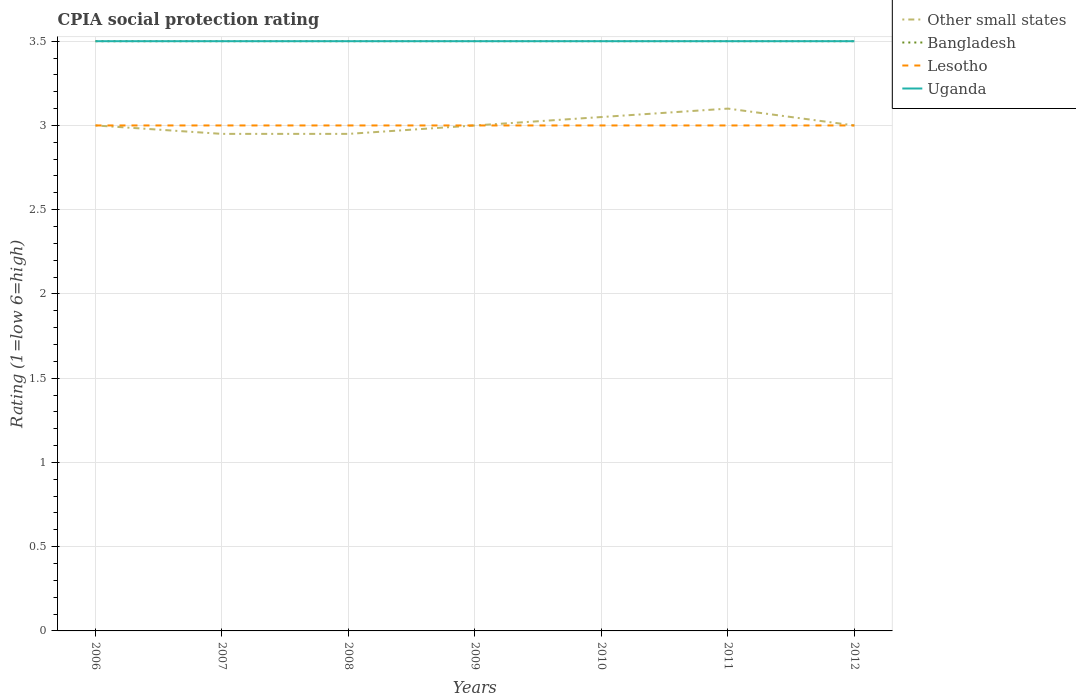How many different coloured lines are there?
Your answer should be very brief. 4. Does the line corresponding to Other small states intersect with the line corresponding to Bangladesh?
Offer a very short reply. No. Is the number of lines equal to the number of legend labels?
Your answer should be very brief. Yes. Across all years, what is the maximum CPIA rating in Lesotho?
Your response must be concise. 3. In which year was the CPIA rating in Other small states maximum?
Provide a succinct answer. 2007. What is the total CPIA rating in Uganda in the graph?
Your response must be concise. 0. What is the difference between the highest and the second highest CPIA rating in Uganda?
Offer a very short reply. 0. What is the difference between the highest and the lowest CPIA rating in Uganda?
Provide a succinct answer. 0. How many lines are there?
Provide a succinct answer. 4. Does the graph contain any zero values?
Make the answer very short. No. Does the graph contain grids?
Make the answer very short. Yes. What is the title of the graph?
Provide a succinct answer. CPIA social protection rating. What is the label or title of the Y-axis?
Provide a succinct answer. Rating (1=low 6=high). What is the Rating (1=low 6=high) of Bangladesh in 2006?
Offer a terse response. 3.5. What is the Rating (1=low 6=high) of Lesotho in 2006?
Ensure brevity in your answer.  3. What is the Rating (1=low 6=high) of Other small states in 2007?
Make the answer very short. 2.95. What is the Rating (1=low 6=high) of Bangladesh in 2007?
Ensure brevity in your answer.  3.5. What is the Rating (1=low 6=high) of Uganda in 2007?
Offer a very short reply. 3.5. What is the Rating (1=low 6=high) of Other small states in 2008?
Offer a very short reply. 2.95. What is the Rating (1=low 6=high) of Bangladesh in 2008?
Give a very brief answer. 3.5. What is the Rating (1=low 6=high) in Uganda in 2008?
Offer a very short reply. 3.5. What is the Rating (1=low 6=high) in Bangladesh in 2009?
Offer a terse response. 3.5. What is the Rating (1=low 6=high) of Uganda in 2009?
Give a very brief answer. 3.5. What is the Rating (1=low 6=high) of Other small states in 2010?
Offer a very short reply. 3.05. What is the Rating (1=low 6=high) of Bangladesh in 2010?
Provide a short and direct response. 3.5. What is the Rating (1=low 6=high) in Uganda in 2010?
Ensure brevity in your answer.  3.5. What is the Rating (1=low 6=high) of Lesotho in 2011?
Provide a short and direct response. 3. What is the Rating (1=low 6=high) in Bangladesh in 2012?
Offer a very short reply. 3.5. Across all years, what is the maximum Rating (1=low 6=high) of Uganda?
Offer a very short reply. 3.5. Across all years, what is the minimum Rating (1=low 6=high) of Other small states?
Provide a short and direct response. 2.95. Across all years, what is the minimum Rating (1=low 6=high) of Bangladesh?
Keep it short and to the point. 3.5. Across all years, what is the minimum Rating (1=low 6=high) of Lesotho?
Your answer should be very brief. 3. Across all years, what is the minimum Rating (1=low 6=high) in Uganda?
Offer a very short reply. 3.5. What is the total Rating (1=low 6=high) in Other small states in the graph?
Ensure brevity in your answer.  21.05. What is the total Rating (1=low 6=high) of Bangladesh in the graph?
Your response must be concise. 24.5. What is the total Rating (1=low 6=high) in Uganda in the graph?
Your answer should be very brief. 24.5. What is the difference between the Rating (1=low 6=high) in Lesotho in 2006 and that in 2007?
Provide a succinct answer. 0. What is the difference between the Rating (1=low 6=high) in Other small states in 2006 and that in 2008?
Your answer should be very brief. 0.05. What is the difference between the Rating (1=low 6=high) in Bangladesh in 2006 and that in 2008?
Keep it short and to the point. 0. What is the difference between the Rating (1=low 6=high) of Lesotho in 2006 and that in 2008?
Offer a very short reply. 0. What is the difference between the Rating (1=low 6=high) in Other small states in 2006 and that in 2009?
Your answer should be very brief. 0. What is the difference between the Rating (1=low 6=high) in Bangladesh in 2006 and that in 2009?
Give a very brief answer. 0. What is the difference between the Rating (1=low 6=high) of Lesotho in 2006 and that in 2009?
Keep it short and to the point. 0. What is the difference between the Rating (1=low 6=high) in Uganda in 2006 and that in 2009?
Ensure brevity in your answer.  0. What is the difference between the Rating (1=low 6=high) of Other small states in 2006 and that in 2010?
Offer a terse response. -0.05. What is the difference between the Rating (1=low 6=high) in Bangladesh in 2006 and that in 2010?
Your response must be concise. 0. What is the difference between the Rating (1=low 6=high) in Other small states in 2006 and that in 2012?
Give a very brief answer. 0. What is the difference between the Rating (1=low 6=high) of Bangladesh in 2006 and that in 2012?
Your response must be concise. 0. What is the difference between the Rating (1=low 6=high) in Bangladesh in 2007 and that in 2008?
Ensure brevity in your answer.  0. What is the difference between the Rating (1=low 6=high) of Uganda in 2007 and that in 2008?
Provide a short and direct response. 0. What is the difference between the Rating (1=low 6=high) in Bangladesh in 2007 and that in 2009?
Your response must be concise. 0. What is the difference between the Rating (1=low 6=high) of Lesotho in 2007 and that in 2009?
Offer a terse response. 0. What is the difference between the Rating (1=low 6=high) in Uganda in 2007 and that in 2009?
Your response must be concise. 0. What is the difference between the Rating (1=low 6=high) of Other small states in 2007 and that in 2010?
Offer a terse response. -0.1. What is the difference between the Rating (1=low 6=high) of Lesotho in 2007 and that in 2010?
Ensure brevity in your answer.  0. What is the difference between the Rating (1=low 6=high) of Other small states in 2007 and that in 2012?
Make the answer very short. -0.05. What is the difference between the Rating (1=low 6=high) of Bangladesh in 2007 and that in 2012?
Your answer should be very brief. 0. What is the difference between the Rating (1=low 6=high) in Other small states in 2008 and that in 2009?
Offer a terse response. -0.05. What is the difference between the Rating (1=low 6=high) in Bangladesh in 2008 and that in 2009?
Keep it short and to the point. 0. What is the difference between the Rating (1=low 6=high) in Uganda in 2008 and that in 2009?
Offer a terse response. 0. What is the difference between the Rating (1=low 6=high) in Bangladesh in 2008 and that in 2010?
Give a very brief answer. 0. What is the difference between the Rating (1=low 6=high) in Lesotho in 2008 and that in 2010?
Offer a terse response. 0. What is the difference between the Rating (1=low 6=high) in Uganda in 2008 and that in 2010?
Your answer should be compact. 0. What is the difference between the Rating (1=low 6=high) of Bangladesh in 2008 and that in 2011?
Give a very brief answer. 0. What is the difference between the Rating (1=low 6=high) in Bangladesh in 2008 and that in 2012?
Your answer should be compact. 0. What is the difference between the Rating (1=low 6=high) of Uganda in 2008 and that in 2012?
Ensure brevity in your answer.  0. What is the difference between the Rating (1=low 6=high) in Other small states in 2009 and that in 2010?
Offer a very short reply. -0.05. What is the difference between the Rating (1=low 6=high) in Bangladesh in 2009 and that in 2010?
Make the answer very short. 0. What is the difference between the Rating (1=low 6=high) in Uganda in 2009 and that in 2010?
Ensure brevity in your answer.  0. What is the difference between the Rating (1=low 6=high) of Bangladesh in 2009 and that in 2011?
Ensure brevity in your answer.  0. What is the difference between the Rating (1=low 6=high) in Uganda in 2009 and that in 2012?
Provide a short and direct response. 0. What is the difference between the Rating (1=low 6=high) in Other small states in 2010 and that in 2011?
Your response must be concise. -0.05. What is the difference between the Rating (1=low 6=high) in Lesotho in 2010 and that in 2011?
Your answer should be very brief. 0. What is the difference between the Rating (1=low 6=high) of Lesotho in 2010 and that in 2012?
Give a very brief answer. 0. What is the difference between the Rating (1=low 6=high) of Uganda in 2010 and that in 2012?
Keep it short and to the point. 0. What is the difference between the Rating (1=low 6=high) in Other small states in 2011 and that in 2012?
Your answer should be compact. 0.1. What is the difference between the Rating (1=low 6=high) in Bangladesh in 2011 and that in 2012?
Make the answer very short. 0. What is the difference between the Rating (1=low 6=high) in Lesotho in 2011 and that in 2012?
Offer a terse response. 0. What is the difference between the Rating (1=low 6=high) of Other small states in 2006 and the Rating (1=low 6=high) of Bangladesh in 2007?
Your response must be concise. -0.5. What is the difference between the Rating (1=low 6=high) in Bangladesh in 2006 and the Rating (1=low 6=high) in Lesotho in 2007?
Provide a succinct answer. 0.5. What is the difference between the Rating (1=low 6=high) in Lesotho in 2006 and the Rating (1=low 6=high) in Uganda in 2007?
Keep it short and to the point. -0.5. What is the difference between the Rating (1=low 6=high) in Bangladesh in 2006 and the Rating (1=low 6=high) in Uganda in 2008?
Make the answer very short. 0. What is the difference between the Rating (1=low 6=high) of Lesotho in 2006 and the Rating (1=low 6=high) of Uganda in 2008?
Ensure brevity in your answer.  -0.5. What is the difference between the Rating (1=low 6=high) of Other small states in 2006 and the Rating (1=low 6=high) of Uganda in 2009?
Offer a terse response. -0.5. What is the difference between the Rating (1=low 6=high) of Bangladesh in 2006 and the Rating (1=low 6=high) of Lesotho in 2009?
Make the answer very short. 0.5. What is the difference between the Rating (1=low 6=high) of Bangladesh in 2006 and the Rating (1=low 6=high) of Lesotho in 2010?
Your response must be concise. 0.5. What is the difference between the Rating (1=low 6=high) of Lesotho in 2006 and the Rating (1=low 6=high) of Uganda in 2010?
Provide a succinct answer. -0.5. What is the difference between the Rating (1=low 6=high) of Other small states in 2006 and the Rating (1=low 6=high) of Bangladesh in 2011?
Provide a short and direct response. -0.5. What is the difference between the Rating (1=low 6=high) in Other small states in 2006 and the Rating (1=low 6=high) in Uganda in 2011?
Your answer should be very brief. -0.5. What is the difference between the Rating (1=low 6=high) of Bangladesh in 2006 and the Rating (1=low 6=high) of Lesotho in 2011?
Make the answer very short. 0.5. What is the difference between the Rating (1=low 6=high) of Lesotho in 2006 and the Rating (1=low 6=high) of Uganda in 2011?
Provide a short and direct response. -0.5. What is the difference between the Rating (1=low 6=high) of Bangladesh in 2006 and the Rating (1=low 6=high) of Lesotho in 2012?
Ensure brevity in your answer.  0.5. What is the difference between the Rating (1=low 6=high) of Lesotho in 2006 and the Rating (1=low 6=high) of Uganda in 2012?
Give a very brief answer. -0.5. What is the difference between the Rating (1=low 6=high) in Other small states in 2007 and the Rating (1=low 6=high) in Bangladesh in 2008?
Provide a short and direct response. -0.55. What is the difference between the Rating (1=low 6=high) in Other small states in 2007 and the Rating (1=low 6=high) in Lesotho in 2008?
Offer a terse response. -0.05. What is the difference between the Rating (1=low 6=high) in Other small states in 2007 and the Rating (1=low 6=high) in Uganda in 2008?
Your response must be concise. -0.55. What is the difference between the Rating (1=low 6=high) in Lesotho in 2007 and the Rating (1=low 6=high) in Uganda in 2008?
Offer a very short reply. -0.5. What is the difference between the Rating (1=low 6=high) of Other small states in 2007 and the Rating (1=low 6=high) of Bangladesh in 2009?
Offer a terse response. -0.55. What is the difference between the Rating (1=low 6=high) of Other small states in 2007 and the Rating (1=low 6=high) of Uganda in 2009?
Your answer should be compact. -0.55. What is the difference between the Rating (1=low 6=high) of Bangladesh in 2007 and the Rating (1=low 6=high) of Uganda in 2009?
Offer a very short reply. 0. What is the difference between the Rating (1=low 6=high) in Lesotho in 2007 and the Rating (1=low 6=high) in Uganda in 2009?
Ensure brevity in your answer.  -0.5. What is the difference between the Rating (1=low 6=high) of Other small states in 2007 and the Rating (1=low 6=high) of Bangladesh in 2010?
Offer a very short reply. -0.55. What is the difference between the Rating (1=low 6=high) of Other small states in 2007 and the Rating (1=low 6=high) of Lesotho in 2010?
Your response must be concise. -0.05. What is the difference between the Rating (1=low 6=high) of Other small states in 2007 and the Rating (1=low 6=high) of Uganda in 2010?
Your answer should be compact. -0.55. What is the difference between the Rating (1=low 6=high) in Bangladesh in 2007 and the Rating (1=low 6=high) in Uganda in 2010?
Provide a short and direct response. 0. What is the difference between the Rating (1=low 6=high) in Other small states in 2007 and the Rating (1=low 6=high) in Bangladesh in 2011?
Keep it short and to the point. -0.55. What is the difference between the Rating (1=low 6=high) in Other small states in 2007 and the Rating (1=low 6=high) in Lesotho in 2011?
Make the answer very short. -0.05. What is the difference between the Rating (1=low 6=high) in Other small states in 2007 and the Rating (1=low 6=high) in Uganda in 2011?
Ensure brevity in your answer.  -0.55. What is the difference between the Rating (1=low 6=high) in Lesotho in 2007 and the Rating (1=low 6=high) in Uganda in 2011?
Give a very brief answer. -0.5. What is the difference between the Rating (1=low 6=high) in Other small states in 2007 and the Rating (1=low 6=high) in Bangladesh in 2012?
Provide a short and direct response. -0.55. What is the difference between the Rating (1=low 6=high) of Other small states in 2007 and the Rating (1=low 6=high) of Lesotho in 2012?
Offer a very short reply. -0.05. What is the difference between the Rating (1=low 6=high) in Other small states in 2007 and the Rating (1=low 6=high) in Uganda in 2012?
Offer a very short reply. -0.55. What is the difference between the Rating (1=low 6=high) in Other small states in 2008 and the Rating (1=low 6=high) in Bangladesh in 2009?
Your response must be concise. -0.55. What is the difference between the Rating (1=low 6=high) in Other small states in 2008 and the Rating (1=low 6=high) in Uganda in 2009?
Your response must be concise. -0.55. What is the difference between the Rating (1=low 6=high) in Lesotho in 2008 and the Rating (1=low 6=high) in Uganda in 2009?
Ensure brevity in your answer.  -0.5. What is the difference between the Rating (1=low 6=high) of Other small states in 2008 and the Rating (1=low 6=high) of Bangladesh in 2010?
Keep it short and to the point. -0.55. What is the difference between the Rating (1=low 6=high) of Other small states in 2008 and the Rating (1=low 6=high) of Uganda in 2010?
Provide a short and direct response. -0.55. What is the difference between the Rating (1=low 6=high) in Bangladesh in 2008 and the Rating (1=low 6=high) in Uganda in 2010?
Your response must be concise. 0. What is the difference between the Rating (1=low 6=high) in Lesotho in 2008 and the Rating (1=low 6=high) in Uganda in 2010?
Keep it short and to the point. -0.5. What is the difference between the Rating (1=low 6=high) of Other small states in 2008 and the Rating (1=low 6=high) of Bangladesh in 2011?
Your answer should be compact. -0.55. What is the difference between the Rating (1=low 6=high) in Other small states in 2008 and the Rating (1=low 6=high) in Lesotho in 2011?
Your answer should be compact. -0.05. What is the difference between the Rating (1=low 6=high) of Other small states in 2008 and the Rating (1=low 6=high) of Uganda in 2011?
Keep it short and to the point. -0.55. What is the difference between the Rating (1=low 6=high) in Bangladesh in 2008 and the Rating (1=low 6=high) in Uganda in 2011?
Your response must be concise. 0. What is the difference between the Rating (1=low 6=high) of Lesotho in 2008 and the Rating (1=low 6=high) of Uganda in 2011?
Make the answer very short. -0.5. What is the difference between the Rating (1=low 6=high) of Other small states in 2008 and the Rating (1=low 6=high) of Bangladesh in 2012?
Ensure brevity in your answer.  -0.55. What is the difference between the Rating (1=low 6=high) in Other small states in 2008 and the Rating (1=low 6=high) in Uganda in 2012?
Give a very brief answer. -0.55. What is the difference between the Rating (1=low 6=high) in Bangladesh in 2008 and the Rating (1=low 6=high) in Uganda in 2012?
Offer a terse response. 0. What is the difference between the Rating (1=low 6=high) in Other small states in 2009 and the Rating (1=low 6=high) in Lesotho in 2010?
Make the answer very short. 0. What is the difference between the Rating (1=low 6=high) of Bangladesh in 2009 and the Rating (1=low 6=high) of Lesotho in 2010?
Your answer should be compact. 0.5. What is the difference between the Rating (1=low 6=high) in Lesotho in 2009 and the Rating (1=low 6=high) in Uganda in 2010?
Your answer should be compact. -0.5. What is the difference between the Rating (1=low 6=high) of Other small states in 2009 and the Rating (1=low 6=high) of Uganda in 2011?
Provide a short and direct response. -0.5. What is the difference between the Rating (1=low 6=high) in Other small states in 2009 and the Rating (1=low 6=high) in Lesotho in 2012?
Keep it short and to the point. 0. What is the difference between the Rating (1=low 6=high) in Bangladesh in 2009 and the Rating (1=low 6=high) in Lesotho in 2012?
Provide a short and direct response. 0.5. What is the difference between the Rating (1=low 6=high) in Bangladesh in 2009 and the Rating (1=low 6=high) in Uganda in 2012?
Offer a terse response. 0. What is the difference between the Rating (1=low 6=high) of Lesotho in 2009 and the Rating (1=low 6=high) of Uganda in 2012?
Keep it short and to the point. -0.5. What is the difference between the Rating (1=low 6=high) in Other small states in 2010 and the Rating (1=low 6=high) in Bangladesh in 2011?
Your answer should be compact. -0.45. What is the difference between the Rating (1=low 6=high) of Other small states in 2010 and the Rating (1=low 6=high) of Uganda in 2011?
Offer a terse response. -0.45. What is the difference between the Rating (1=low 6=high) of Bangladesh in 2010 and the Rating (1=low 6=high) of Lesotho in 2011?
Offer a terse response. 0.5. What is the difference between the Rating (1=low 6=high) in Bangladesh in 2010 and the Rating (1=low 6=high) in Uganda in 2011?
Your answer should be very brief. 0. What is the difference between the Rating (1=low 6=high) of Other small states in 2010 and the Rating (1=low 6=high) of Bangladesh in 2012?
Make the answer very short. -0.45. What is the difference between the Rating (1=low 6=high) of Other small states in 2010 and the Rating (1=low 6=high) of Uganda in 2012?
Give a very brief answer. -0.45. What is the difference between the Rating (1=low 6=high) of Bangladesh in 2010 and the Rating (1=low 6=high) of Uganda in 2012?
Provide a succinct answer. 0. What is the difference between the Rating (1=low 6=high) of Lesotho in 2010 and the Rating (1=low 6=high) of Uganda in 2012?
Offer a terse response. -0.5. What is the difference between the Rating (1=low 6=high) in Other small states in 2011 and the Rating (1=low 6=high) in Lesotho in 2012?
Provide a short and direct response. 0.1. What is the difference between the Rating (1=low 6=high) of Other small states in 2011 and the Rating (1=low 6=high) of Uganda in 2012?
Keep it short and to the point. -0.4. What is the difference between the Rating (1=low 6=high) in Bangladesh in 2011 and the Rating (1=low 6=high) in Uganda in 2012?
Make the answer very short. 0. What is the difference between the Rating (1=low 6=high) of Lesotho in 2011 and the Rating (1=low 6=high) of Uganda in 2012?
Your answer should be very brief. -0.5. What is the average Rating (1=low 6=high) in Other small states per year?
Provide a succinct answer. 3.01. What is the average Rating (1=low 6=high) in Lesotho per year?
Your answer should be compact. 3. In the year 2006, what is the difference between the Rating (1=low 6=high) of Other small states and Rating (1=low 6=high) of Lesotho?
Give a very brief answer. 0. In the year 2006, what is the difference between the Rating (1=low 6=high) in Other small states and Rating (1=low 6=high) in Uganda?
Ensure brevity in your answer.  -0.5. In the year 2006, what is the difference between the Rating (1=low 6=high) in Bangladesh and Rating (1=low 6=high) in Lesotho?
Your answer should be very brief. 0.5. In the year 2007, what is the difference between the Rating (1=low 6=high) of Other small states and Rating (1=low 6=high) of Bangladesh?
Offer a terse response. -0.55. In the year 2007, what is the difference between the Rating (1=low 6=high) of Other small states and Rating (1=low 6=high) of Lesotho?
Keep it short and to the point. -0.05. In the year 2007, what is the difference between the Rating (1=low 6=high) of Other small states and Rating (1=low 6=high) of Uganda?
Provide a short and direct response. -0.55. In the year 2007, what is the difference between the Rating (1=low 6=high) in Bangladesh and Rating (1=low 6=high) in Lesotho?
Ensure brevity in your answer.  0.5. In the year 2007, what is the difference between the Rating (1=low 6=high) of Bangladesh and Rating (1=low 6=high) of Uganda?
Offer a terse response. 0. In the year 2007, what is the difference between the Rating (1=low 6=high) in Lesotho and Rating (1=low 6=high) in Uganda?
Make the answer very short. -0.5. In the year 2008, what is the difference between the Rating (1=low 6=high) in Other small states and Rating (1=low 6=high) in Bangladesh?
Offer a terse response. -0.55. In the year 2008, what is the difference between the Rating (1=low 6=high) of Other small states and Rating (1=low 6=high) of Uganda?
Offer a very short reply. -0.55. In the year 2009, what is the difference between the Rating (1=low 6=high) of Bangladesh and Rating (1=low 6=high) of Lesotho?
Your answer should be compact. 0.5. In the year 2009, what is the difference between the Rating (1=low 6=high) of Lesotho and Rating (1=low 6=high) of Uganda?
Offer a very short reply. -0.5. In the year 2010, what is the difference between the Rating (1=low 6=high) of Other small states and Rating (1=low 6=high) of Bangladesh?
Your answer should be very brief. -0.45. In the year 2010, what is the difference between the Rating (1=low 6=high) of Other small states and Rating (1=low 6=high) of Uganda?
Your response must be concise. -0.45. In the year 2010, what is the difference between the Rating (1=low 6=high) of Bangladesh and Rating (1=low 6=high) of Lesotho?
Offer a very short reply. 0.5. In the year 2010, what is the difference between the Rating (1=low 6=high) in Bangladesh and Rating (1=low 6=high) in Uganda?
Keep it short and to the point. 0. In the year 2010, what is the difference between the Rating (1=low 6=high) in Lesotho and Rating (1=low 6=high) in Uganda?
Ensure brevity in your answer.  -0.5. In the year 2011, what is the difference between the Rating (1=low 6=high) in Other small states and Rating (1=low 6=high) in Bangladesh?
Offer a very short reply. -0.4. In the year 2011, what is the difference between the Rating (1=low 6=high) of Other small states and Rating (1=low 6=high) of Uganda?
Your answer should be very brief. -0.4. In the year 2011, what is the difference between the Rating (1=low 6=high) in Lesotho and Rating (1=low 6=high) in Uganda?
Ensure brevity in your answer.  -0.5. In the year 2012, what is the difference between the Rating (1=low 6=high) in Other small states and Rating (1=low 6=high) in Bangladesh?
Your answer should be compact. -0.5. In the year 2012, what is the difference between the Rating (1=low 6=high) in Other small states and Rating (1=low 6=high) in Lesotho?
Your answer should be compact. 0. In the year 2012, what is the difference between the Rating (1=low 6=high) in Other small states and Rating (1=low 6=high) in Uganda?
Provide a succinct answer. -0.5. In the year 2012, what is the difference between the Rating (1=low 6=high) of Lesotho and Rating (1=low 6=high) of Uganda?
Keep it short and to the point. -0.5. What is the ratio of the Rating (1=low 6=high) of Other small states in 2006 to that in 2007?
Ensure brevity in your answer.  1.02. What is the ratio of the Rating (1=low 6=high) of Bangladesh in 2006 to that in 2007?
Offer a terse response. 1. What is the ratio of the Rating (1=low 6=high) in Other small states in 2006 to that in 2008?
Ensure brevity in your answer.  1.02. What is the ratio of the Rating (1=low 6=high) of Bangladesh in 2006 to that in 2008?
Your response must be concise. 1. What is the ratio of the Rating (1=low 6=high) of Uganda in 2006 to that in 2009?
Offer a very short reply. 1. What is the ratio of the Rating (1=low 6=high) in Other small states in 2006 to that in 2010?
Keep it short and to the point. 0.98. What is the ratio of the Rating (1=low 6=high) in Bangladesh in 2006 to that in 2010?
Offer a very short reply. 1. What is the ratio of the Rating (1=low 6=high) of Uganda in 2006 to that in 2010?
Your answer should be compact. 1. What is the ratio of the Rating (1=low 6=high) in Other small states in 2006 to that in 2011?
Your answer should be compact. 0.97. What is the ratio of the Rating (1=low 6=high) in Bangladesh in 2006 to that in 2012?
Provide a short and direct response. 1. What is the ratio of the Rating (1=low 6=high) in Uganda in 2006 to that in 2012?
Provide a short and direct response. 1. What is the ratio of the Rating (1=low 6=high) in Other small states in 2007 to that in 2008?
Give a very brief answer. 1. What is the ratio of the Rating (1=low 6=high) of Other small states in 2007 to that in 2009?
Make the answer very short. 0.98. What is the ratio of the Rating (1=low 6=high) in Lesotho in 2007 to that in 2009?
Provide a succinct answer. 1. What is the ratio of the Rating (1=low 6=high) in Uganda in 2007 to that in 2009?
Keep it short and to the point. 1. What is the ratio of the Rating (1=low 6=high) in Other small states in 2007 to that in 2010?
Your answer should be very brief. 0.97. What is the ratio of the Rating (1=low 6=high) of Lesotho in 2007 to that in 2010?
Offer a very short reply. 1. What is the ratio of the Rating (1=low 6=high) in Uganda in 2007 to that in 2010?
Make the answer very short. 1. What is the ratio of the Rating (1=low 6=high) of Other small states in 2007 to that in 2011?
Your answer should be very brief. 0.95. What is the ratio of the Rating (1=low 6=high) in Bangladesh in 2007 to that in 2011?
Make the answer very short. 1. What is the ratio of the Rating (1=low 6=high) of Uganda in 2007 to that in 2011?
Your answer should be compact. 1. What is the ratio of the Rating (1=low 6=high) of Other small states in 2007 to that in 2012?
Your answer should be very brief. 0.98. What is the ratio of the Rating (1=low 6=high) of Bangladesh in 2007 to that in 2012?
Offer a very short reply. 1. What is the ratio of the Rating (1=low 6=high) of Lesotho in 2007 to that in 2012?
Provide a short and direct response. 1. What is the ratio of the Rating (1=low 6=high) in Other small states in 2008 to that in 2009?
Make the answer very short. 0.98. What is the ratio of the Rating (1=low 6=high) of Bangladesh in 2008 to that in 2009?
Your answer should be very brief. 1. What is the ratio of the Rating (1=low 6=high) of Uganda in 2008 to that in 2009?
Your response must be concise. 1. What is the ratio of the Rating (1=low 6=high) in Other small states in 2008 to that in 2010?
Offer a very short reply. 0.97. What is the ratio of the Rating (1=low 6=high) in Bangladesh in 2008 to that in 2010?
Offer a terse response. 1. What is the ratio of the Rating (1=low 6=high) of Uganda in 2008 to that in 2010?
Offer a terse response. 1. What is the ratio of the Rating (1=low 6=high) of Other small states in 2008 to that in 2011?
Your answer should be compact. 0.95. What is the ratio of the Rating (1=low 6=high) of Bangladesh in 2008 to that in 2011?
Ensure brevity in your answer.  1. What is the ratio of the Rating (1=low 6=high) in Lesotho in 2008 to that in 2011?
Give a very brief answer. 1. What is the ratio of the Rating (1=low 6=high) in Uganda in 2008 to that in 2011?
Offer a very short reply. 1. What is the ratio of the Rating (1=low 6=high) in Other small states in 2008 to that in 2012?
Your response must be concise. 0.98. What is the ratio of the Rating (1=low 6=high) of Lesotho in 2008 to that in 2012?
Your response must be concise. 1. What is the ratio of the Rating (1=low 6=high) in Uganda in 2008 to that in 2012?
Your answer should be very brief. 1. What is the ratio of the Rating (1=low 6=high) in Other small states in 2009 to that in 2010?
Make the answer very short. 0.98. What is the ratio of the Rating (1=low 6=high) in Lesotho in 2009 to that in 2010?
Provide a short and direct response. 1. What is the ratio of the Rating (1=low 6=high) of Uganda in 2009 to that in 2010?
Provide a succinct answer. 1. What is the ratio of the Rating (1=low 6=high) of Bangladesh in 2009 to that in 2011?
Your answer should be very brief. 1. What is the ratio of the Rating (1=low 6=high) of Lesotho in 2009 to that in 2011?
Make the answer very short. 1. What is the ratio of the Rating (1=low 6=high) of Other small states in 2009 to that in 2012?
Provide a short and direct response. 1. What is the ratio of the Rating (1=low 6=high) in Uganda in 2009 to that in 2012?
Your response must be concise. 1. What is the ratio of the Rating (1=low 6=high) in Other small states in 2010 to that in 2011?
Keep it short and to the point. 0.98. What is the ratio of the Rating (1=low 6=high) of Lesotho in 2010 to that in 2011?
Provide a short and direct response. 1. What is the ratio of the Rating (1=low 6=high) of Uganda in 2010 to that in 2011?
Provide a short and direct response. 1. What is the ratio of the Rating (1=low 6=high) of Other small states in 2010 to that in 2012?
Offer a very short reply. 1.02. What is the ratio of the Rating (1=low 6=high) of Bangladesh in 2010 to that in 2012?
Your answer should be very brief. 1. What is the ratio of the Rating (1=low 6=high) in Lesotho in 2010 to that in 2012?
Give a very brief answer. 1. What is the ratio of the Rating (1=low 6=high) in Uganda in 2010 to that in 2012?
Provide a short and direct response. 1. What is the ratio of the Rating (1=low 6=high) of Other small states in 2011 to that in 2012?
Give a very brief answer. 1.03. What is the ratio of the Rating (1=low 6=high) of Bangladesh in 2011 to that in 2012?
Make the answer very short. 1. What is the ratio of the Rating (1=low 6=high) of Lesotho in 2011 to that in 2012?
Your response must be concise. 1. What is the difference between the highest and the second highest Rating (1=low 6=high) of Other small states?
Your answer should be very brief. 0.05. What is the difference between the highest and the lowest Rating (1=low 6=high) of Other small states?
Your answer should be compact. 0.15. What is the difference between the highest and the lowest Rating (1=low 6=high) in Bangladesh?
Provide a succinct answer. 0. 